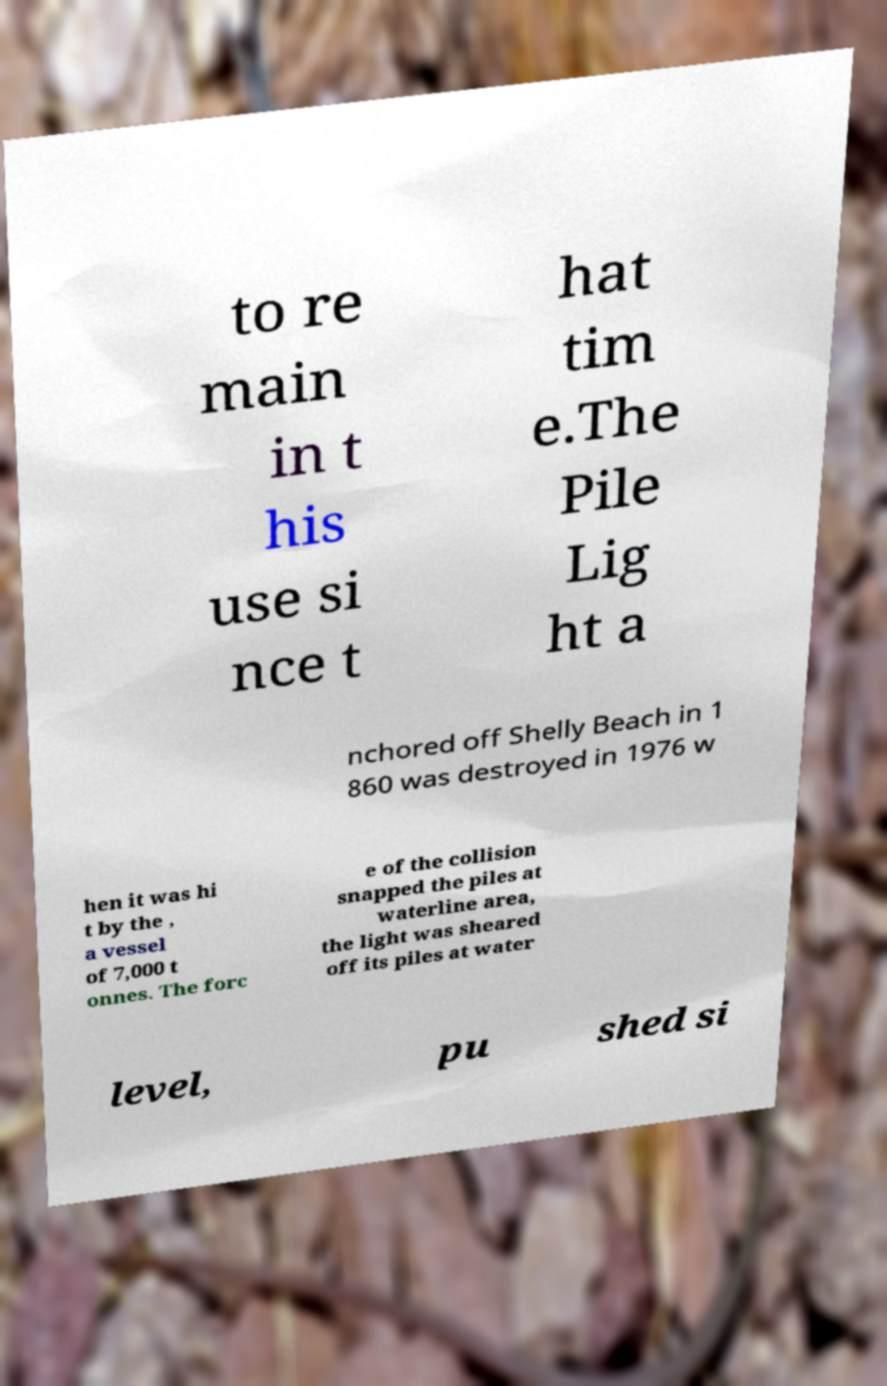Please identify and transcribe the text found in this image. to re main in t his use si nce t hat tim e.The Pile Lig ht a nchored off Shelly Beach in 1 860 was destroyed in 1976 w hen it was hi t by the , a vessel of 7,000 t onnes. The forc e of the collision snapped the piles at waterline area, the light was sheared off its piles at water level, pu shed si 